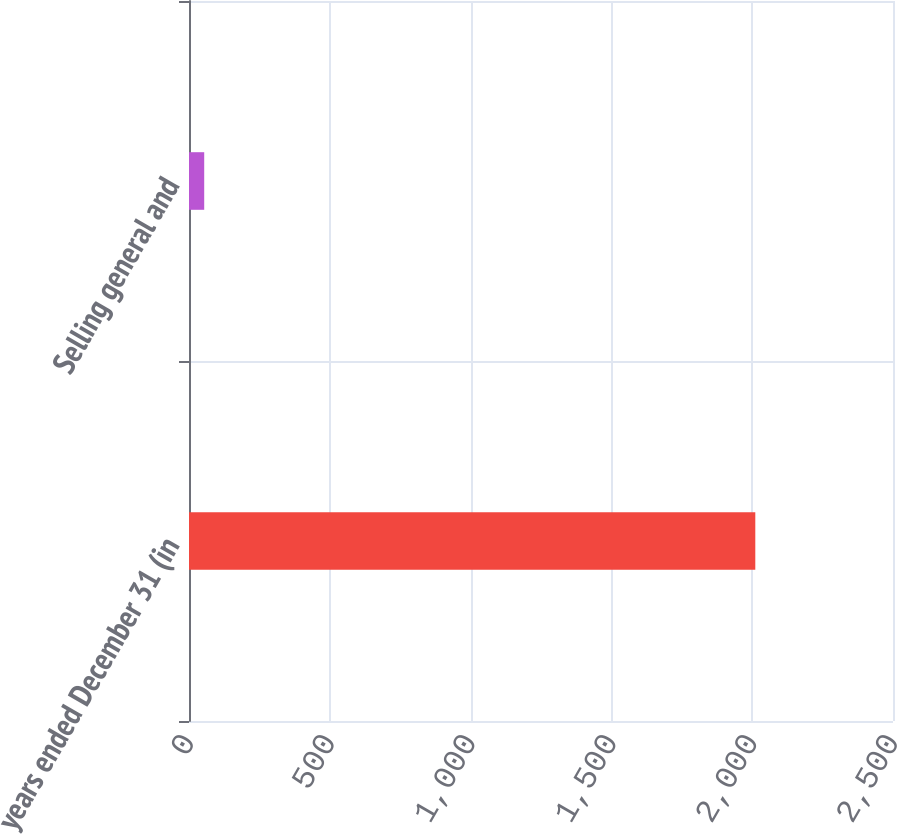<chart> <loc_0><loc_0><loc_500><loc_500><bar_chart><fcel>years ended December 31 (in<fcel>Selling general and<nl><fcel>2011<fcel>54<nl></chart> 